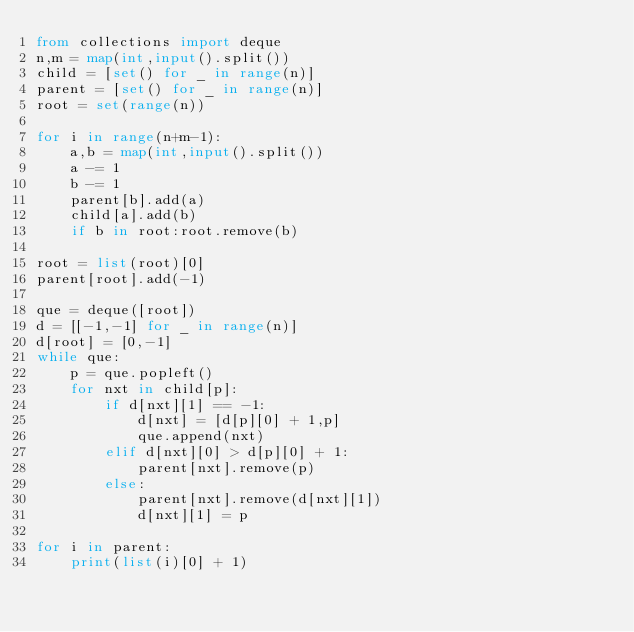<code> <loc_0><loc_0><loc_500><loc_500><_Python_>from collections import deque
n,m = map(int,input().split())
child = [set() for _ in range(n)]
parent = [set() for _ in range(n)]
root = set(range(n))

for i in range(n+m-1):
    a,b = map(int,input().split())
    a -= 1
    b -= 1
    parent[b].add(a)
    child[a].add(b)
    if b in root:root.remove(b)

root = list(root)[0]
parent[root].add(-1)

que = deque([root])
d = [[-1,-1] for _ in range(n)]
d[root] = [0,-1]
while que:
    p = que.popleft()
    for nxt in child[p]:
        if d[nxt][1] == -1:
            d[nxt] = [d[p][0] + 1,p]
            que.append(nxt)
        elif d[nxt][0] > d[p][0] + 1:
            parent[nxt].remove(p)
        else:
            parent[nxt].remove(d[nxt][1])
            d[nxt][1] = p

for i in parent:
    print(list(i)[0] + 1)
</code> 